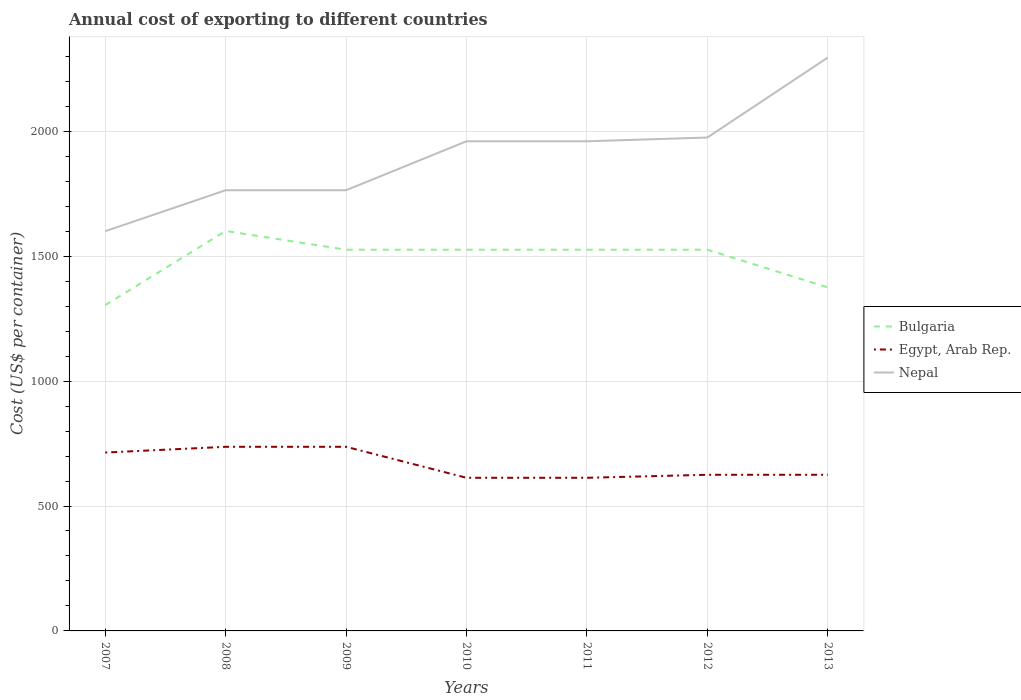Across all years, what is the maximum total annual cost of exporting in Egypt, Arab Rep.?
Keep it short and to the point. 613. What is the total total annual cost of exporting in Egypt, Arab Rep. in the graph?
Your answer should be very brief. 101. What is the difference between the highest and the second highest total annual cost of exporting in Bulgaria?
Provide a succinct answer. 297. Is the total annual cost of exporting in Nepal strictly greater than the total annual cost of exporting in Bulgaria over the years?
Provide a short and direct response. No. How many lines are there?
Your answer should be very brief. 3. How many years are there in the graph?
Offer a very short reply. 7. What is the title of the graph?
Offer a terse response. Annual cost of exporting to different countries. What is the label or title of the Y-axis?
Your answer should be compact. Cost (US$ per container). What is the Cost (US$ per container) in Bulgaria in 2007?
Keep it short and to the point. 1304. What is the Cost (US$ per container) in Egypt, Arab Rep. in 2007?
Your answer should be compact. 714. What is the Cost (US$ per container) in Nepal in 2007?
Provide a succinct answer. 1600. What is the Cost (US$ per container) of Bulgaria in 2008?
Make the answer very short. 1601. What is the Cost (US$ per container) in Egypt, Arab Rep. in 2008?
Your response must be concise. 737. What is the Cost (US$ per container) in Nepal in 2008?
Ensure brevity in your answer.  1764. What is the Cost (US$ per container) in Bulgaria in 2009?
Your answer should be compact. 1526. What is the Cost (US$ per container) of Egypt, Arab Rep. in 2009?
Your answer should be very brief. 737. What is the Cost (US$ per container) in Nepal in 2009?
Your answer should be very brief. 1764. What is the Cost (US$ per container) of Bulgaria in 2010?
Offer a very short reply. 1526. What is the Cost (US$ per container) of Egypt, Arab Rep. in 2010?
Your answer should be very brief. 613. What is the Cost (US$ per container) in Nepal in 2010?
Make the answer very short. 1960. What is the Cost (US$ per container) of Bulgaria in 2011?
Keep it short and to the point. 1526. What is the Cost (US$ per container) in Egypt, Arab Rep. in 2011?
Keep it short and to the point. 613. What is the Cost (US$ per container) of Nepal in 2011?
Offer a very short reply. 1960. What is the Cost (US$ per container) in Bulgaria in 2012?
Your answer should be compact. 1526. What is the Cost (US$ per container) of Egypt, Arab Rep. in 2012?
Your answer should be compact. 625. What is the Cost (US$ per container) in Nepal in 2012?
Your response must be concise. 1975. What is the Cost (US$ per container) of Bulgaria in 2013?
Ensure brevity in your answer.  1375. What is the Cost (US$ per container) in Egypt, Arab Rep. in 2013?
Provide a short and direct response. 625. What is the Cost (US$ per container) of Nepal in 2013?
Make the answer very short. 2295. Across all years, what is the maximum Cost (US$ per container) in Bulgaria?
Offer a very short reply. 1601. Across all years, what is the maximum Cost (US$ per container) in Egypt, Arab Rep.?
Make the answer very short. 737. Across all years, what is the maximum Cost (US$ per container) in Nepal?
Your response must be concise. 2295. Across all years, what is the minimum Cost (US$ per container) in Bulgaria?
Provide a short and direct response. 1304. Across all years, what is the minimum Cost (US$ per container) in Egypt, Arab Rep.?
Offer a terse response. 613. Across all years, what is the minimum Cost (US$ per container) of Nepal?
Ensure brevity in your answer.  1600. What is the total Cost (US$ per container) of Bulgaria in the graph?
Provide a succinct answer. 1.04e+04. What is the total Cost (US$ per container) of Egypt, Arab Rep. in the graph?
Provide a succinct answer. 4664. What is the total Cost (US$ per container) in Nepal in the graph?
Your response must be concise. 1.33e+04. What is the difference between the Cost (US$ per container) in Bulgaria in 2007 and that in 2008?
Your response must be concise. -297. What is the difference between the Cost (US$ per container) of Egypt, Arab Rep. in 2007 and that in 2008?
Give a very brief answer. -23. What is the difference between the Cost (US$ per container) in Nepal in 2007 and that in 2008?
Your answer should be very brief. -164. What is the difference between the Cost (US$ per container) of Bulgaria in 2007 and that in 2009?
Your response must be concise. -222. What is the difference between the Cost (US$ per container) in Egypt, Arab Rep. in 2007 and that in 2009?
Your answer should be compact. -23. What is the difference between the Cost (US$ per container) in Nepal in 2007 and that in 2009?
Make the answer very short. -164. What is the difference between the Cost (US$ per container) of Bulgaria in 2007 and that in 2010?
Provide a succinct answer. -222. What is the difference between the Cost (US$ per container) of Egypt, Arab Rep. in 2007 and that in 2010?
Keep it short and to the point. 101. What is the difference between the Cost (US$ per container) in Nepal in 2007 and that in 2010?
Your answer should be compact. -360. What is the difference between the Cost (US$ per container) in Bulgaria in 2007 and that in 2011?
Keep it short and to the point. -222. What is the difference between the Cost (US$ per container) of Egypt, Arab Rep. in 2007 and that in 2011?
Offer a terse response. 101. What is the difference between the Cost (US$ per container) of Nepal in 2007 and that in 2011?
Ensure brevity in your answer.  -360. What is the difference between the Cost (US$ per container) in Bulgaria in 2007 and that in 2012?
Offer a very short reply. -222. What is the difference between the Cost (US$ per container) of Egypt, Arab Rep. in 2007 and that in 2012?
Offer a very short reply. 89. What is the difference between the Cost (US$ per container) in Nepal in 2007 and that in 2012?
Keep it short and to the point. -375. What is the difference between the Cost (US$ per container) in Bulgaria in 2007 and that in 2013?
Your answer should be very brief. -71. What is the difference between the Cost (US$ per container) of Egypt, Arab Rep. in 2007 and that in 2013?
Provide a short and direct response. 89. What is the difference between the Cost (US$ per container) of Nepal in 2007 and that in 2013?
Ensure brevity in your answer.  -695. What is the difference between the Cost (US$ per container) of Bulgaria in 2008 and that in 2009?
Provide a succinct answer. 75. What is the difference between the Cost (US$ per container) of Egypt, Arab Rep. in 2008 and that in 2009?
Provide a succinct answer. 0. What is the difference between the Cost (US$ per container) in Nepal in 2008 and that in 2009?
Your answer should be very brief. 0. What is the difference between the Cost (US$ per container) of Egypt, Arab Rep. in 2008 and that in 2010?
Your answer should be very brief. 124. What is the difference between the Cost (US$ per container) of Nepal in 2008 and that in 2010?
Ensure brevity in your answer.  -196. What is the difference between the Cost (US$ per container) in Egypt, Arab Rep. in 2008 and that in 2011?
Ensure brevity in your answer.  124. What is the difference between the Cost (US$ per container) of Nepal in 2008 and that in 2011?
Ensure brevity in your answer.  -196. What is the difference between the Cost (US$ per container) of Bulgaria in 2008 and that in 2012?
Your answer should be compact. 75. What is the difference between the Cost (US$ per container) in Egypt, Arab Rep. in 2008 and that in 2012?
Your answer should be very brief. 112. What is the difference between the Cost (US$ per container) in Nepal in 2008 and that in 2012?
Keep it short and to the point. -211. What is the difference between the Cost (US$ per container) in Bulgaria in 2008 and that in 2013?
Your answer should be very brief. 226. What is the difference between the Cost (US$ per container) in Egypt, Arab Rep. in 2008 and that in 2013?
Offer a very short reply. 112. What is the difference between the Cost (US$ per container) in Nepal in 2008 and that in 2013?
Offer a terse response. -531. What is the difference between the Cost (US$ per container) in Egypt, Arab Rep. in 2009 and that in 2010?
Provide a succinct answer. 124. What is the difference between the Cost (US$ per container) in Nepal in 2009 and that in 2010?
Keep it short and to the point. -196. What is the difference between the Cost (US$ per container) in Bulgaria in 2009 and that in 2011?
Provide a short and direct response. 0. What is the difference between the Cost (US$ per container) of Egypt, Arab Rep. in 2009 and that in 2011?
Provide a short and direct response. 124. What is the difference between the Cost (US$ per container) in Nepal in 2009 and that in 2011?
Your answer should be compact. -196. What is the difference between the Cost (US$ per container) of Bulgaria in 2009 and that in 2012?
Offer a terse response. 0. What is the difference between the Cost (US$ per container) in Egypt, Arab Rep. in 2009 and that in 2012?
Keep it short and to the point. 112. What is the difference between the Cost (US$ per container) of Nepal in 2009 and that in 2012?
Offer a terse response. -211. What is the difference between the Cost (US$ per container) of Bulgaria in 2009 and that in 2013?
Your response must be concise. 151. What is the difference between the Cost (US$ per container) in Egypt, Arab Rep. in 2009 and that in 2013?
Give a very brief answer. 112. What is the difference between the Cost (US$ per container) in Nepal in 2009 and that in 2013?
Make the answer very short. -531. What is the difference between the Cost (US$ per container) of Bulgaria in 2010 and that in 2011?
Offer a very short reply. 0. What is the difference between the Cost (US$ per container) in Bulgaria in 2010 and that in 2013?
Your response must be concise. 151. What is the difference between the Cost (US$ per container) of Egypt, Arab Rep. in 2010 and that in 2013?
Your response must be concise. -12. What is the difference between the Cost (US$ per container) of Nepal in 2010 and that in 2013?
Your answer should be compact. -335. What is the difference between the Cost (US$ per container) in Bulgaria in 2011 and that in 2013?
Your response must be concise. 151. What is the difference between the Cost (US$ per container) in Egypt, Arab Rep. in 2011 and that in 2013?
Offer a very short reply. -12. What is the difference between the Cost (US$ per container) in Nepal in 2011 and that in 2013?
Provide a short and direct response. -335. What is the difference between the Cost (US$ per container) of Bulgaria in 2012 and that in 2013?
Give a very brief answer. 151. What is the difference between the Cost (US$ per container) of Egypt, Arab Rep. in 2012 and that in 2013?
Ensure brevity in your answer.  0. What is the difference between the Cost (US$ per container) in Nepal in 2012 and that in 2013?
Keep it short and to the point. -320. What is the difference between the Cost (US$ per container) of Bulgaria in 2007 and the Cost (US$ per container) of Egypt, Arab Rep. in 2008?
Make the answer very short. 567. What is the difference between the Cost (US$ per container) of Bulgaria in 2007 and the Cost (US$ per container) of Nepal in 2008?
Ensure brevity in your answer.  -460. What is the difference between the Cost (US$ per container) in Egypt, Arab Rep. in 2007 and the Cost (US$ per container) in Nepal in 2008?
Provide a short and direct response. -1050. What is the difference between the Cost (US$ per container) of Bulgaria in 2007 and the Cost (US$ per container) of Egypt, Arab Rep. in 2009?
Offer a terse response. 567. What is the difference between the Cost (US$ per container) in Bulgaria in 2007 and the Cost (US$ per container) in Nepal in 2009?
Provide a succinct answer. -460. What is the difference between the Cost (US$ per container) of Egypt, Arab Rep. in 2007 and the Cost (US$ per container) of Nepal in 2009?
Provide a succinct answer. -1050. What is the difference between the Cost (US$ per container) in Bulgaria in 2007 and the Cost (US$ per container) in Egypt, Arab Rep. in 2010?
Keep it short and to the point. 691. What is the difference between the Cost (US$ per container) in Bulgaria in 2007 and the Cost (US$ per container) in Nepal in 2010?
Keep it short and to the point. -656. What is the difference between the Cost (US$ per container) of Egypt, Arab Rep. in 2007 and the Cost (US$ per container) of Nepal in 2010?
Provide a short and direct response. -1246. What is the difference between the Cost (US$ per container) in Bulgaria in 2007 and the Cost (US$ per container) in Egypt, Arab Rep. in 2011?
Ensure brevity in your answer.  691. What is the difference between the Cost (US$ per container) of Bulgaria in 2007 and the Cost (US$ per container) of Nepal in 2011?
Offer a terse response. -656. What is the difference between the Cost (US$ per container) in Egypt, Arab Rep. in 2007 and the Cost (US$ per container) in Nepal in 2011?
Offer a terse response. -1246. What is the difference between the Cost (US$ per container) in Bulgaria in 2007 and the Cost (US$ per container) in Egypt, Arab Rep. in 2012?
Keep it short and to the point. 679. What is the difference between the Cost (US$ per container) in Bulgaria in 2007 and the Cost (US$ per container) in Nepal in 2012?
Your answer should be compact. -671. What is the difference between the Cost (US$ per container) in Egypt, Arab Rep. in 2007 and the Cost (US$ per container) in Nepal in 2012?
Give a very brief answer. -1261. What is the difference between the Cost (US$ per container) in Bulgaria in 2007 and the Cost (US$ per container) in Egypt, Arab Rep. in 2013?
Offer a terse response. 679. What is the difference between the Cost (US$ per container) of Bulgaria in 2007 and the Cost (US$ per container) of Nepal in 2013?
Provide a short and direct response. -991. What is the difference between the Cost (US$ per container) in Egypt, Arab Rep. in 2007 and the Cost (US$ per container) in Nepal in 2013?
Your answer should be very brief. -1581. What is the difference between the Cost (US$ per container) in Bulgaria in 2008 and the Cost (US$ per container) in Egypt, Arab Rep. in 2009?
Keep it short and to the point. 864. What is the difference between the Cost (US$ per container) in Bulgaria in 2008 and the Cost (US$ per container) in Nepal in 2009?
Provide a short and direct response. -163. What is the difference between the Cost (US$ per container) in Egypt, Arab Rep. in 2008 and the Cost (US$ per container) in Nepal in 2009?
Offer a terse response. -1027. What is the difference between the Cost (US$ per container) of Bulgaria in 2008 and the Cost (US$ per container) of Egypt, Arab Rep. in 2010?
Your answer should be very brief. 988. What is the difference between the Cost (US$ per container) of Bulgaria in 2008 and the Cost (US$ per container) of Nepal in 2010?
Ensure brevity in your answer.  -359. What is the difference between the Cost (US$ per container) in Egypt, Arab Rep. in 2008 and the Cost (US$ per container) in Nepal in 2010?
Provide a succinct answer. -1223. What is the difference between the Cost (US$ per container) in Bulgaria in 2008 and the Cost (US$ per container) in Egypt, Arab Rep. in 2011?
Offer a terse response. 988. What is the difference between the Cost (US$ per container) of Bulgaria in 2008 and the Cost (US$ per container) of Nepal in 2011?
Provide a succinct answer. -359. What is the difference between the Cost (US$ per container) of Egypt, Arab Rep. in 2008 and the Cost (US$ per container) of Nepal in 2011?
Offer a very short reply. -1223. What is the difference between the Cost (US$ per container) in Bulgaria in 2008 and the Cost (US$ per container) in Egypt, Arab Rep. in 2012?
Make the answer very short. 976. What is the difference between the Cost (US$ per container) of Bulgaria in 2008 and the Cost (US$ per container) of Nepal in 2012?
Provide a succinct answer. -374. What is the difference between the Cost (US$ per container) in Egypt, Arab Rep. in 2008 and the Cost (US$ per container) in Nepal in 2012?
Ensure brevity in your answer.  -1238. What is the difference between the Cost (US$ per container) in Bulgaria in 2008 and the Cost (US$ per container) in Egypt, Arab Rep. in 2013?
Your answer should be compact. 976. What is the difference between the Cost (US$ per container) of Bulgaria in 2008 and the Cost (US$ per container) of Nepal in 2013?
Give a very brief answer. -694. What is the difference between the Cost (US$ per container) in Egypt, Arab Rep. in 2008 and the Cost (US$ per container) in Nepal in 2013?
Make the answer very short. -1558. What is the difference between the Cost (US$ per container) of Bulgaria in 2009 and the Cost (US$ per container) of Egypt, Arab Rep. in 2010?
Give a very brief answer. 913. What is the difference between the Cost (US$ per container) in Bulgaria in 2009 and the Cost (US$ per container) in Nepal in 2010?
Provide a short and direct response. -434. What is the difference between the Cost (US$ per container) of Egypt, Arab Rep. in 2009 and the Cost (US$ per container) of Nepal in 2010?
Give a very brief answer. -1223. What is the difference between the Cost (US$ per container) of Bulgaria in 2009 and the Cost (US$ per container) of Egypt, Arab Rep. in 2011?
Your answer should be compact. 913. What is the difference between the Cost (US$ per container) in Bulgaria in 2009 and the Cost (US$ per container) in Nepal in 2011?
Your answer should be very brief. -434. What is the difference between the Cost (US$ per container) in Egypt, Arab Rep. in 2009 and the Cost (US$ per container) in Nepal in 2011?
Give a very brief answer. -1223. What is the difference between the Cost (US$ per container) in Bulgaria in 2009 and the Cost (US$ per container) in Egypt, Arab Rep. in 2012?
Ensure brevity in your answer.  901. What is the difference between the Cost (US$ per container) of Bulgaria in 2009 and the Cost (US$ per container) of Nepal in 2012?
Ensure brevity in your answer.  -449. What is the difference between the Cost (US$ per container) of Egypt, Arab Rep. in 2009 and the Cost (US$ per container) of Nepal in 2012?
Ensure brevity in your answer.  -1238. What is the difference between the Cost (US$ per container) of Bulgaria in 2009 and the Cost (US$ per container) of Egypt, Arab Rep. in 2013?
Make the answer very short. 901. What is the difference between the Cost (US$ per container) in Bulgaria in 2009 and the Cost (US$ per container) in Nepal in 2013?
Your answer should be compact. -769. What is the difference between the Cost (US$ per container) of Egypt, Arab Rep. in 2009 and the Cost (US$ per container) of Nepal in 2013?
Provide a short and direct response. -1558. What is the difference between the Cost (US$ per container) in Bulgaria in 2010 and the Cost (US$ per container) in Egypt, Arab Rep. in 2011?
Provide a short and direct response. 913. What is the difference between the Cost (US$ per container) in Bulgaria in 2010 and the Cost (US$ per container) in Nepal in 2011?
Keep it short and to the point. -434. What is the difference between the Cost (US$ per container) in Egypt, Arab Rep. in 2010 and the Cost (US$ per container) in Nepal in 2011?
Ensure brevity in your answer.  -1347. What is the difference between the Cost (US$ per container) of Bulgaria in 2010 and the Cost (US$ per container) of Egypt, Arab Rep. in 2012?
Give a very brief answer. 901. What is the difference between the Cost (US$ per container) of Bulgaria in 2010 and the Cost (US$ per container) of Nepal in 2012?
Ensure brevity in your answer.  -449. What is the difference between the Cost (US$ per container) of Egypt, Arab Rep. in 2010 and the Cost (US$ per container) of Nepal in 2012?
Offer a very short reply. -1362. What is the difference between the Cost (US$ per container) in Bulgaria in 2010 and the Cost (US$ per container) in Egypt, Arab Rep. in 2013?
Keep it short and to the point. 901. What is the difference between the Cost (US$ per container) of Bulgaria in 2010 and the Cost (US$ per container) of Nepal in 2013?
Give a very brief answer. -769. What is the difference between the Cost (US$ per container) in Egypt, Arab Rep. in 2010 and the Cost (US$ per container) in Nepal in 2013?
Give a very brief answer. -1682. What is the difference between the Cost (US$ per container) of Bulgaria in 2011 and the Cost (US$ per container) of Egypt, Arab Rep. in 2012?
Your answer should be very brief. 901. What is the difference between the Cost (US$ per container) in Bulgaria in 2011 and the Cost (US$ per container) in Nepal in 2012?
Make the answer very short. -449. What is the difference between the Cost (US$ per container) in Egypt, Arab Rep. in 2011 and the Cost (US$ per container) in Nepal in 2012?
Provide a succinct answer. -1362. What is the difference between the Cost (US$ per container) in Bulgaria in 2011 and the Cost (US$ per container) in Egypt, Arab Rep. in 2013?
Ensure brevity in your answer.  901. What is the difference between the Cost (US$ per container) in Bulgaria in 2011 and the Cost (US$ per container) in Nepal in 2013?
Offer a very short reply. -769. What is the difference between the Cost (US$ per container) in Egypt, Arab Rep. in 2011 and the Cost (US$ per container) in Nepal in 2013?
Provide a succinct answer. -1682. What is the difference between the Cost (US$ per container) in Bulgaria in 2012 and the Cost (US$ per container) in Egypt, Arab Rep. in 2013?
Your answer should be compact. 901. What is the difference between the Cost (US$ per container) in Bulgaria in 2012 and the Cost (US$ per container) in Nepal in 2013?
Offer a terse response. -769. What is the difference between the Cost (US$ per container) in Egypt, Arab Rep. in 2012 and the Cost (US$ per container) in Nepal in 2013?
Give a very brief answer. -1670. What is the average Cost (US$ per container) in Bulgaria per year?
Your answer should be very brief. 1483.43. What is the average Cost (US$ per container) of Egypt, Arab Rep. per year?
Your answer should be compact. 666.29. What is the average Cost (US$ per container) in Nepal per year?
Offer a terse response. 1902.57. In the year 2007, what is the difference between the Cost (US$ per container) in Bulgaria and Cost (US$ per container) in Egypt, Arab Rep.?
Give a very brief answer. 590. In the year 2007, what is the difference between the Cost (US$ per container) in Bulgaria and Cost (US$ per container) in Nepal?
Provide a short and direct response. -296. In the year 2007, what is the difference between the Cost (US$ per container) of Egypt, Arab Rep. and Cost (US$ per container) of Nepal?
Offer a terse response. -886. In the year 2008, what is the difference between the Cost (US$ per container) in Bulgaria and Cost (US$ per container) in Egypt, Arab Rep.?
Offer a terse response. 864. In the year 2008, what is the difference between the Cost (US$ per container) in Bulgaria and Cost (US$ per container) in Nepal?
Your answer should be very brief. -163. In the year 2008, what is the difference between the Cost (US$ per container) in Egypt, Arab Rep. and Cost (US$ per container) in Nepal?
Make the answer very short. -1027. In the year 2009, what is the difference between the Cost (US$ per container) in Bulgaria and Cost (US$ per container) in Egypt, Arab Rep.?
Make the answer very short. 789. In the year 2009, what is the difference between the Cost (US$ per container) in Bulgaria and Cost (US$ per container) in Nepal?
Provide a succinct answer. -238. In the year 2009, what is the difference between the Cost (US$ per container) of Egypt, Arab Rep. and Cost (US$ per container) of Nepal?
Keep it short and to the point. -1027. In the year 2010, what is the difference between the Cost (US$ per container) in Bulgaria and Cost (US$ per container) in Egypt, Arab Rep.?
Offer a terse response. 913. In the year 2010, what is the difference between the Cost (US$ per container) in Bulgaria and Cost (US$ per container) in Nepal?
Offer a terse response. -434. In the year 2010, what is the difference between the Cost (US$ per container) in Egypt, Arab Rep. and Cost (US$ per container) in Nepal?
Offer a terse response. -1347. In the year 2011, what is the difference between the Cost (US$ per container) of Bulgaria and Cost (US$ per container) of Egypt, Arab Rep.?
Your answer should be compact. 913. In the year 2011, what is the difference between the Cost (US$ per container) of Bulgaria and Cost (US$ per container) of Nepal?
Your answer should be compact. -434. In the year 2011, what is the difference between the Cost (US$ per container) of Egypt, Arab Rep. and Cost (US$ per container) of Nepal?
Offer a terse response. -1347. In the year 2012, what is the difference between the Cost (US$ per container) in Bulgaria and Cost (US$ per container) in Egypt, Arab Rep.?
Make the answer very short. 901. In the year 2012, what is the difference between the Cost (US$ per container) in Bulgaria and Cost (US$ per container) in Nepal?
Keep it short and to the point. -449. In the year 2012, what is the difference between the Cost (US$ per container) in Egypt, Arab Rep. and Cost (US$ per container) in Nepal?
Make the answer very short. -1350. In the year 2013, what is the difference between the Cost (US$ per container) in Bulgaria and Cost (US$ per container) in Egypt, Arab Rep.?
Offer a very short reply. 750. In the year 2013, what is the difference between the Cost (US$ per container) in Bulgaria and Cost (US$ per container) in Nepal?
Provide a short and direct response. -920. In the year 2013, what is the difference between the Cost (US$ per container) in Egypt, Arab Rep. and Cost (US$ per container) in Nepal?
Provide a short and direct response. -1670. What is the ratio of the Cost (US$ per container) in Bulgaria in 2007 to that in 2008?
Your answer should be compact. 0.81. What is the ratio of the Cost (US$ per container) of Egypt, Arab Rep. in 2007 to that in 2008?
Offer a terse response. 0.97. What is the ratio of the Cost (US$ per container) of Nepal in 2007 to that in 2008?
Provide a succinct answer. 0.91. What is the ratio of the Cost (US$ per container) of Bulgaria in 2007 to that in 2009?
Offer a very short reply. 0.85. What is the ratio of the Cost (US$ per container) in Egypt, Arab Rep. in 2007 to that in 2009?
Offer a terse response. 0.97. What is the ratio of the Cost (US$ per container) of Nepal in 2007 to that in 2009?
Your answer should be very brief. 0.91. What is the ratio of the Cost (US$ per container) in Bulgaria in 2007 to that in 2010?
Give a very brief answer. 0.85. What is the ratio of the Cost (US$ per container) in Egypt, Arab Rep. in 2007 to that in 2010?
Your answer should be compact. 1.16. What is the ratio of the Cost (US$ per container) in Nepal in 2007 to that in 2010?
Give a very brief answer. 0.82. What is the ratio of the Cost (US$ per container) of Bulgaria in 2007 to that in 2011?
Ensure brevity in your answer.  0.85. What is the ratio of the Cost (US$ per container) in Egypt, Arab Rep. in 2007 to that in 2011?
Provide a succinct answer. 1.16. What is the ratio of the Cost (US$ per container) of Nepal in 2007 to that in 2011?
Offer a very short reply. 0.82. What is the ratio of the Cost (US$ per container) of Bulgaria in 2007 to that in 2012?
Make the answer very short. 0.85. What is the ratio of the Cost (US$ per container) in Egypt, Arab Rep. in 2007 to that in 2012?
Give a very brief answer. 1.14. What is the ratio of the Cost (US$ per container) of Nepal in 2007 to that in 2012?
Give a very brief answer. 0.81. What is the ratio of the Cost (US$ per container) in Bulgaria in 2007 to that in 2013?
Keep it short and to the point. 0.95. What is the ratio of the Cost (US$ per container) in Egypt, Arab Rep. in 2007 to that in 2013?
Provide a short and direct response. 1.14. What is the ratio of the Cost (US$ per container) in Nepal in 2007 to that in 2013?
Keep it short and to the point. 0.7. What is the ratio of the Cost (US$ per container) in Bulgaria in 2008 to that in 2009?
Offer a terse response. 1.05. What is the ratio of the Cost (US$ per container) of Nepal in 2008 to that in 2009?
Make the answer very short. 1. What is the ratio of the Cost (US$ per container) of Bulgaria in 2008 to that in 2010?
Your answer should be compact. 1.05. What is the ratio of the Cost (US$ per container) of Egypt, Arab Rep. in 2008 to that in 2010?
Make the answer very short. 1.2. What is the ratio of the Cost (US$ per container) in Nepal in 2008 to that in 2010?
Ensure brevity in your answer.  0.9. What is the ratio of the Cost (US$ per container) in Bulgaria in 2008 to that in 2011?
Give a very brief answer. 1.05. What is the ratio of the Cost (US$ per container) of Egypt, Arab Rep. in 2008 to that in 2011?
Offer a very short reply. 1.2. What is the ratio of the Cost (US$ per container) of Nepal in 2008 to that in 2011?
Your answer should be compact. 0.9. What is the ratio of the Cost (US$ per container) of Bulgaria in 2008 to that in 2012?
Give a very brief answer. 1.05. What is the ratio of the Cost (US$ per container) in Egypt, Arab Rep. in 2008 to that in 2012?
Your answer should be very brief. 1.18. What is the ratio of the Cost (US$ per container) of Nepal in 2008 to that in 2012?
Offer a terse response. 0.89. What is the ratio of the Cost (US$ per container) in Bulgaria in 2008 to that in 2013?
Give a very brief answer. 1.16. What is the ratio of the Cost (US$ per container) in Egypt, Arab Rep. in 2008 to that in 2013?
Make the answer very short. 1.18. What is the ratio of the Cost (US$ per container) of Nepal in 2008 to that in 2013?
Your answer should be very brief. 0.77. What is the ratio of the Cost (US$ per container) of Egypt, Arab Rep. in 2009 to that in 2010?
Give a very brief answer. 1.2. What is the ratio of the Cost (US$ per container) of Bulgaria in 2009 to that in 2011?
Your answer should be very brief. 1. What is the ratio of the Cost (US$ per container) of Egypt, Arab Rep. in 2009 to that in 2011?
Offer a terse response. 1.2. What is the ratio of the Cost (US$ per container) in Nepal in 2009 to that in 2011?
Keep it short and to the point. 0.9. What is the ratio of the Cost (US$ per container) of Bulgaria in 2009 to that in 2012?
Give a very brief answer. 1. What is the ratio of the Cost (US$ per container) in Egypt, Arab Rep. in 2009 to that in 2012?
Your response must be concise. 1.18. What is the ratio of the Cost (US$ per container) in Nepal in 2009 to that in 2012?
Keep it short and to the point. 0.89. What is the ratio of the Cost (US$ per container) in Bulgaria in 2009 to that in 2013?
Your answer should be compact. 1.11. What is the ratio of the Cost (US$ per container) in Egypt, Arab Rep. in 2009 to that in 2013?
Offer a terse response. 1.18. What is the ratio of the Cost (US$ per container) of Nepal in 2009 to that in 2013?
Your response must be concise. 0.77. What is the ratio of the Cost (US$ per container) in Bulgaria in 2010 to that in 2011?
Make the answer very short. 1. What is the ratio of the Cost (US$ per container) of Egypt, Arab Rep. in 2010 to that in 2011?
Keep it short and to the point. 1. What is the ratio of the Cost (US$ per container) in Nepal in 2010 to that in 2011?
Keep it short and to the point. 1. What is the ratio of the Cost (US$ per container) of Bulgaria in 2010 to that in 2012?
Offer a terse response. 1. What is the ratio of the Cost (US$ per container) of Egypt, Arab Rep. in 2010 to that in 2012?
Provide a succinct answer. 0.98. What is the ratio of the Cost (US$ per container) in Bulgaria in 2010 to that in 2013?
Give a very brief answer. 1.11. What is the ratio of the Cost (US$ per container) in Egypt, Arab Rep. in 2010 to that in 2013?
Give a very brief answer. 0.98. What is the ratio of the Cost (US$ per container) of Nepal in 2010 to that in 2013?
Your response must be concise. 0.85. What is the ratio of the Cost (US$ per container) of Egypt, Arab Rep. in 2011 to that in 2012?
Make the answer very short. 0.98. What is the ratio of the Cost (US$ per container) in Nepal in 2011 to that in 2012?
Offer a terse response. 0.99. What is the ratio of the Cost (US$ per container) in Bulgaria in 2011 to that in 2013?
Ensure brevity in your answer.  1.11. What is the ratio of the Cost (US$ per container) of Egypt, Arab Rep. in 2011 to that in 2013?
Offer a very short reply. 0.98. What is the ratio of the Cost (US$ per container) of Nepal in 2011 to that in 2013?
Your answer should be very brief. 0.85. What is the ratio of the Cost (US$ per container) in Bulgaria in 2012 to that in 2013?
Provide a succinct answer. 1.11. What is the ratio of the Cost (US$ per container) of Nepal in 2012 to that in 2013?
Offer a very short reply. 0.86. What is the difference between the highest and the second highest Cost (US$ per container) in Nepal?
Make the answer very short. 320. What is the difference between the highest and the lowest Cost (US$ per container) of Bulgaria?
Your response must be concise. 297. What is the difference between the highest and the lowest Cost (US$ per container) in Egypt, Arab Rep.?
Provide a succinct answer. 124. What is the difference between the highest and the lowest Cost (US$ per container) of Nepal?
Offer a very short reply. 695. 